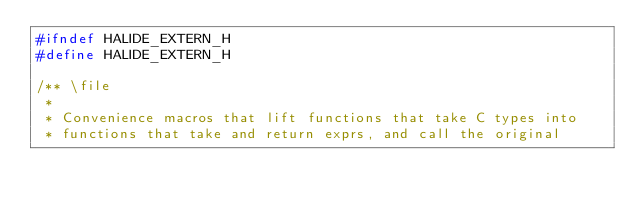<code> <loc_0><loc_0><loc_500><loc_500><_C_>#ifndef HALIDE_EXTERN_H
#define HALIDE_EXTERN_H

/** \file
 *
 * Convenience macros that lift functions that take C types into
 * functions that take and return exprs, and call the original</code> 